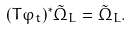<formula> <loc_0><loc_0><loc_500><loc_500>( T \varphi _ { t } ) ^ { * } \tilde { \Omega } _ { L } = \tilde { \Omega } _ { L } .</formula> 